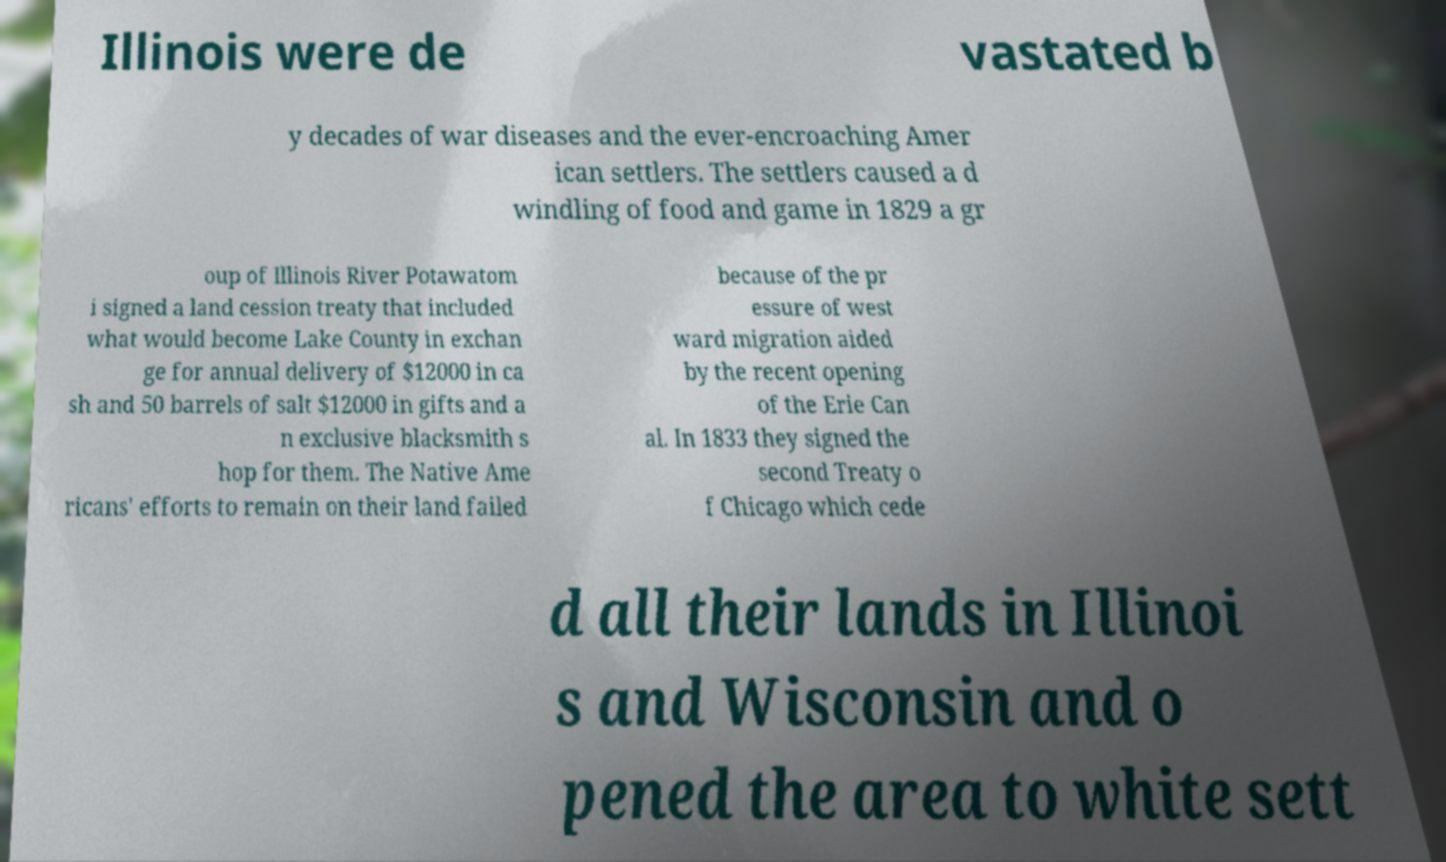What messages or text are displayed in this image? I need them in a readable, typed format. Illinois were de vastated b y decades of war diseases and the ever-encroaching Amer ican settlers. The settlers caused a d windling of food and game in 1829 a gr oup of Illinois River Potawatom i signed a land cession treaty that included what would become Lake County in exchan ge for annual delivery of $12000 in ca sh and 50 barrels of salt $12000 in gifts and a n exclusive blacksmith s hop for them. The Native Ame ricans' efforts to remain on their land failed because of the pr essure of west ward migration aided by the recent opening of the Erie Can al. In 1833 they signed the second Treaty o f Chicago which cede d all their lands in Illinoi s and Wisconsin and o pened the area to white sett 